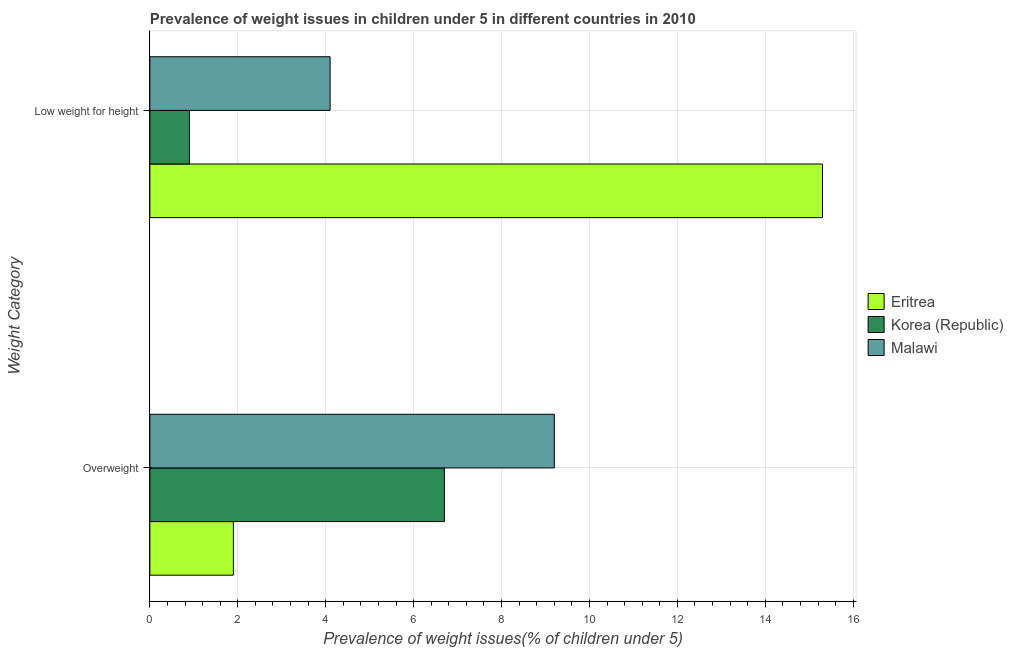Are the number of bars per tick equal to the number of legend labels?
Your answer should be compact. Yes. How many bars are there on the 2nd tick from the bottom?
Provide a succinct answer. 3. What is the label of the 2nd group of bars from the top?
Offer a terse response. Overweight. What is the percentage of underweight children in Korea (Republic)?
Provide a succinct answer. 0.9. Across all countries, what is the maximum percentage of underweight children?
Your answer should be very brief. 15.3. Across all countries, what is the minimum percentage of overweight children?
Your answer should be compact. 1.9. In which country was the percentage of underweight children maximum?
Ensure brevity in your answer.  Eritrea. In which country was the percentage of underweight children minimum?
Provide a succinct answer. Korea (Republic). What is the total percentage of overweight children in the graph?
Offer a terse response. 17.8. What is the difference between the percentage of underweight children in Korea (Republic) and that in Eritrea?
Your response must be concise. -14.4. What is the difference between the percentage of overweight children in Korea (Republic) and the percentage of underweight children in Eritrea?
Make the answer very short. -8.6. What is the average percentage of underweight children per country?
Give a very brief answer. 6.77. What is the difference between the percentage of underweight children and percentage of overweight children in Korea (Republic)?
Offer a very short reply. -5.8. In how many countries, is the percentage of overweight children greater than 4.4 %?
Provide a short and direct response. 2. What is the ratio of the percentage of overweight children in Malawi to that in Korea (Republic)?
Provide a succinct answer. 1.37. In how many countries, is the percentage of overweight children greater than the average percentage of overweight children taken over all countries?
Your answer should be compact. 2. What does the 1st bar from the top in Overweight represents?
Your answer should be very brief. Malawi. What does the 3rd bar from the bottom in Overweight represents?
Offer a very short reply. Malawi. How many bars are there?
Give a very brief answer. 6. Does the graph contain grids?
Ensure brevity in your answer.  Yes. How many legend labels are there?
Make the answer very short. 3. What is the title of the graph?
Make the answer very short. Prevalence of weight issues in children under 5 in different countries in 2010. What is the label or title of the X-axis?
Offer a very short reply. Prevalence of weight issues(% of children under 5). What is the label or title of the Y-axis?
Keep it short and to the point. Weight Category. What is the Prevalence of weight issues(% of children under 5) of Eritrea in Overweight?
Provide a succinct answer. 1.9. What is the Prevalence of weight issues(% of children under 5) in Korea (Republic) in Overweight?
Provide a short and direct response. 6.7. What is the Prevalence of weight issues(% of children under 5) of Malawi in Overweight?
Your answer should be very brief. 9.2. What is the Prevalence of weight issues(% of children under 5) of Eritrea in Low weight for height?
Your answer should be very brief. 15.3. What is the Prevalence of weight issues(% of children under 5) in Korea (Republic) in Low weight for height?
Provide a short and direct response. 0.9. What is the Prevalence of weight issues(% of children under 5) of Malawi in Low weight for height?
Provide a short and direct response. 4.1. Across all Weight Category, what is the maximum Prevalence of weight issues(% of children under 5) in Eritrea?
Offer a terse response. 15.3. Across all Weight Category, what is the maximum Prevalence of weight issues(% of children under 5) in Korea (Republic)?
Your answer should be very brief. 6.7. Across all Weight Category, what is the maximum Prevalence of weight issues(% of children under 5) of Malawi?
Ensure brevity in your answer.  9.2. Across all Weight Category, what is the minimum Prevalence of weight issues(% of children under 5) of Eritrea?
Provide a short and direct response. 1.9. Across all Weight Category, what is the minimum Prevalence of weight issues(% of children under 5) in Korea (Republic)?
Offer a terse response. 0.9. Across all Weight Category, what is the minimum Prevalence of weight issues(% of children under 5) of Malawi?
Offer a very short reply. 4.1. What is the total Prevalence of weight issues(% of children under 5) in Korea (Republic) in the graph?
Provide a succinct answer. 7.6. What is the difference between the Prevalence of weight issues(% of children under 5) in Korea (Republic) in Overweight and that in Low weight for height?
Make the answer very short. 5.8. What is the difference between the Prevalence of weight issues(% of children under 5) of Eritrea in Overweight and the Prevalence of weight issues(% of children under 5) of Korea (Republic) in Low weight for height?
Your answer should be compact. 1. What is the difference between the Prevalence of weight issues(% of children under 5) of Korea (Republic) in Overweight and the Prevalence of weight issues(% of children under 5) of Malawi in Low weight for height?
Your answer should be very brief. 2.6. What is the average Prevalence of weight issues(% of children under 5) in Eritrea per Weight Category?
Your answer should be very brief. 8.6. What is the average Prevalence of weight issues(% of children under 5) in Malawi per Weight Category?
Offer a terse response. 6.65. What is the difference between the Prevalence of weight issues(% of children under 5) of Eritrea and Prevalence of weight issues(% of children under 5) of Korea (Republic) in Overweight?
Provide a succinct answer. -4.8. What is the difference between the Prevalence of weight issues(% of children under 5) in Korea (Republic) and Prevalence of weight issues(% of children under 5) in Malawi in Overweight?
Offer a very short reply. -2.5. What is the difference between the Prevalence of weight issues(% of children under 5) of Eritrea and Prevalence of weight issues(% of children under 5) of Korea (Republic) in Low weight for height?
Provide a short and direct response. 14.4. What is the ratio of the Prevalence of weight issues(% of children under 5) of Eritrea in Overweight to that in Low weight for height?
Provide a short and direct response. 0.12. What is the ratio of the Prevalence of weight issues(% of children under 5) in Korea (Republic) in Overweight to that in Low weight for height?
Offer a terse response. 7.44. What is the ratio of the Prevalence of weight issues(% of children under 5) of Malawi in Overweight to that in Low weight for height?
Offer a very short reply. 2.24. What is the difference between the highest and the second highest Prevalence of weight issues(% of children under 5) in Eritrea?
Provide a succinct answer. 13.4. What is the difference between the highest and the second highest Prevalence of weight issues(% of children under 5) of Korea (Republic)?
Offer a terse response. 5.8. What is the difference between the highest and the second highest Prevalence of weight issues(% of children under 5) of Malawi?
Your answer should be very brief. 5.1. 